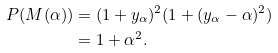Convert formula to latex. <formula><loc_0><loc_0><loc_500><loc_500>P ( M ( \alpha ) ) & = ( 1 + y _ { \alpha } ) ^ { 2 } ( 1 + ( y _ { \alpha } - \alpha ) ^ { 2 } ) \\ & = 1 + \alpha ^ { 2 } .</formula> 